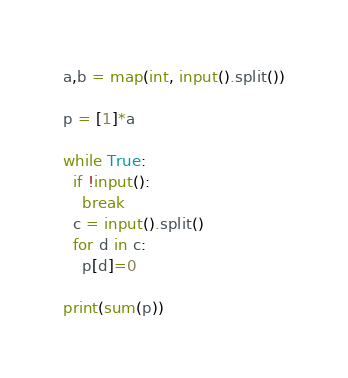Convert code to text. <code><loc_0><loc_0><loc_500><loc_500><_Python_>a,b = map(int, input().split())

p = [1]*a

while True:
  if !input():
    break
  c = input().split()
  for d in c:
    p[d]=0

print(sum(p))</code> 